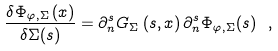Convert formula to latex. <formula><loc_0><loc_0><loc_500><loc_500>\frac { \delta { \Phi _ { \varphi , \Sigma } } \left ( x \right ) } { \delta \Sigma ( s ) } = \partial _ { n } ^ { s } G _ { \Sigma } \left ( s , x \right ) \partial _ { n } ^ { s } { \Phi _ { \varphi , \Sigma } } ( s ) \ ,</formula> 